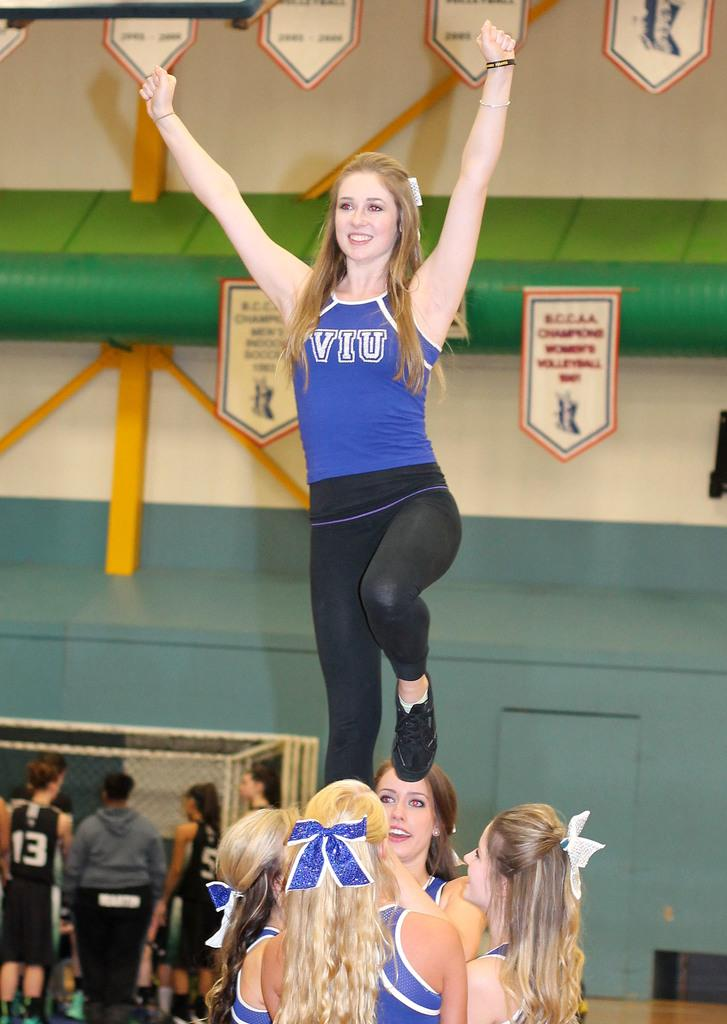<image>
Give a short and clear explanation of the subsequent image. A cheerleader standing wearing a shirt that says VIU. 